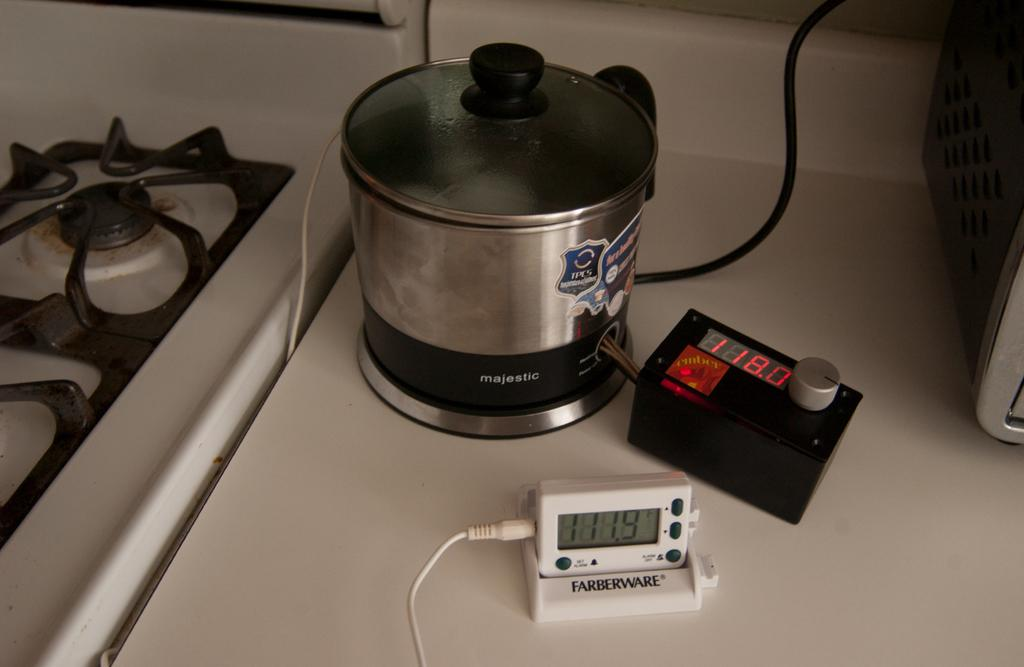What type of appliance can be seen in the image? There is a stove in the image. What can be found on the table in the image? There are electrical objects on a table in the image. How many pairs of shoes are visible in the image? There are no shoes visible in the image. What type of zephyr can be seen blowing through the kitchen in the image? There is no zephyr present in the image. 